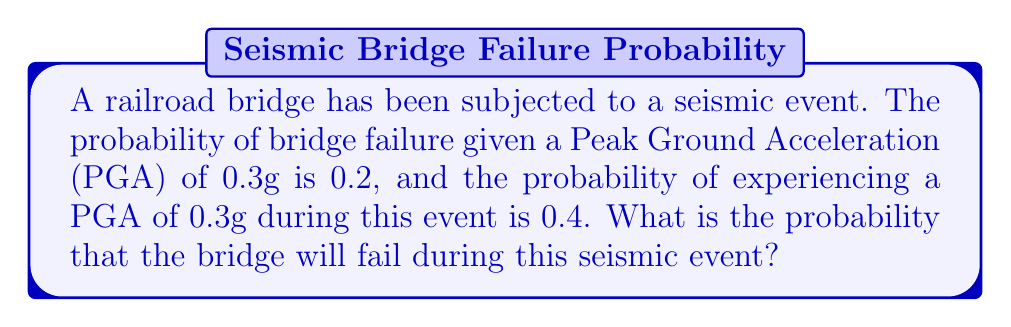Help me with this question. To solve this problem, we need to use the law of total probability. Let's break it down step by step:

1. Define the events:
   $F$: Bridge failure
   $A$: PGA of 0.3g occurs

2. Given information:
   $P(F|A) = 0.2$ (probability of failure given 0.3g PGA)
   $P(A) = 0.4$ (probability of 0.3g PGA occurring)

3. We need to find $P(F)$, which can be calculated using the law of total probability:

   $$P(F) = P(F|A) \cdot P(A) + P(F|\overline{A}) \cdot P(\overline{A})$$

   Where $\overline{A}$ represents the event that a PGA of 0.3g does not occur.

4. We know $P(F|A)$ and $P(A)$, but we don't have information about $P(F|\overline{A})$. However, we can assume that the probability of failure is lower when the PGA is less than 0.3g. For this problem, let's assume $P(F|\overline{A}) = 0.05$.

5. Calculate $P(\overline{A})$:
   $$P(\overline{A}) = 1 - P(A) = 1 - 0.4 = 0.6$$

6. Now we can substitute all values into the equation:

   $$P(F) = 0.2 \cdot 0.4 + 0.05 \cdot 0.6$$

7. Calculate:
   $$P(F) = 0.08 + 0.03 = 0.11$$

Therefore, the probability that the bridge will fail during this seismic event is 0.11 or 11%.
Answer: 0.11 